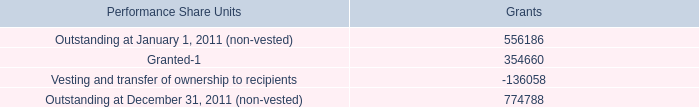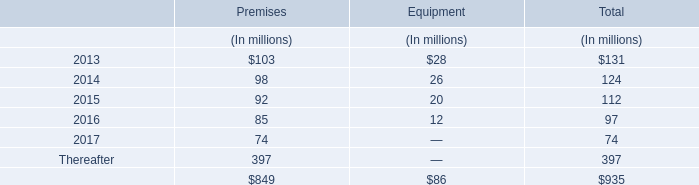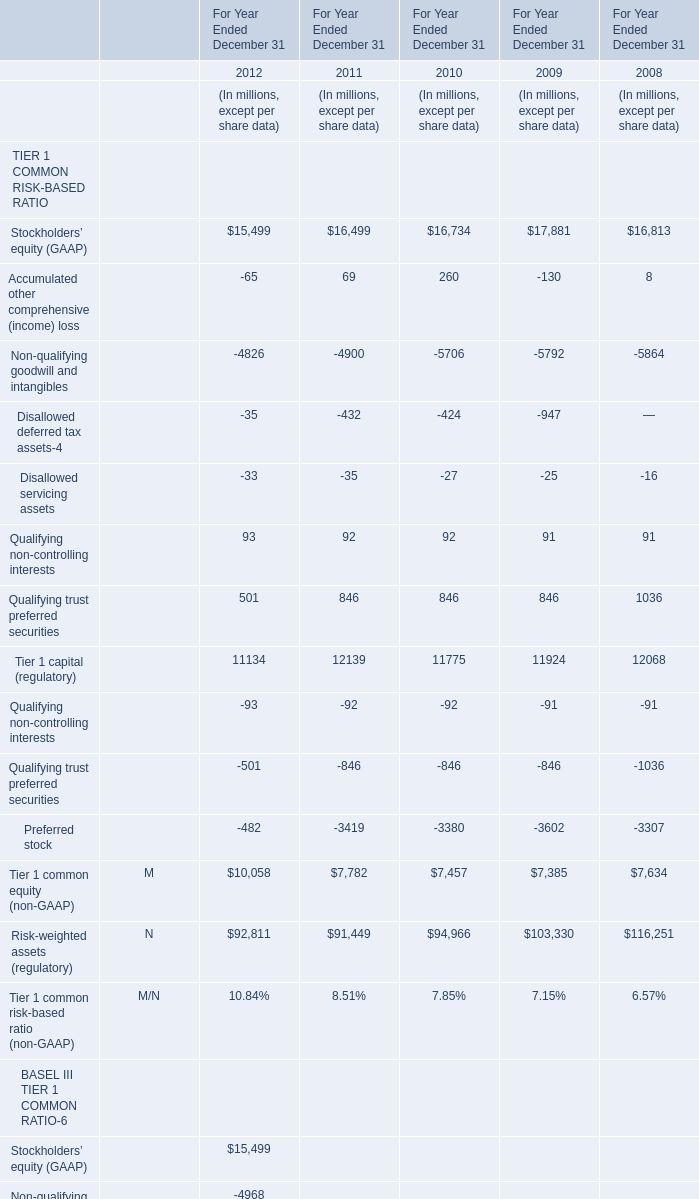in 2011 what was the percent of the change in the performance shares outstanding 
Computations: ((774788 - 556186) / 556186)
Answer: 0.39304. 